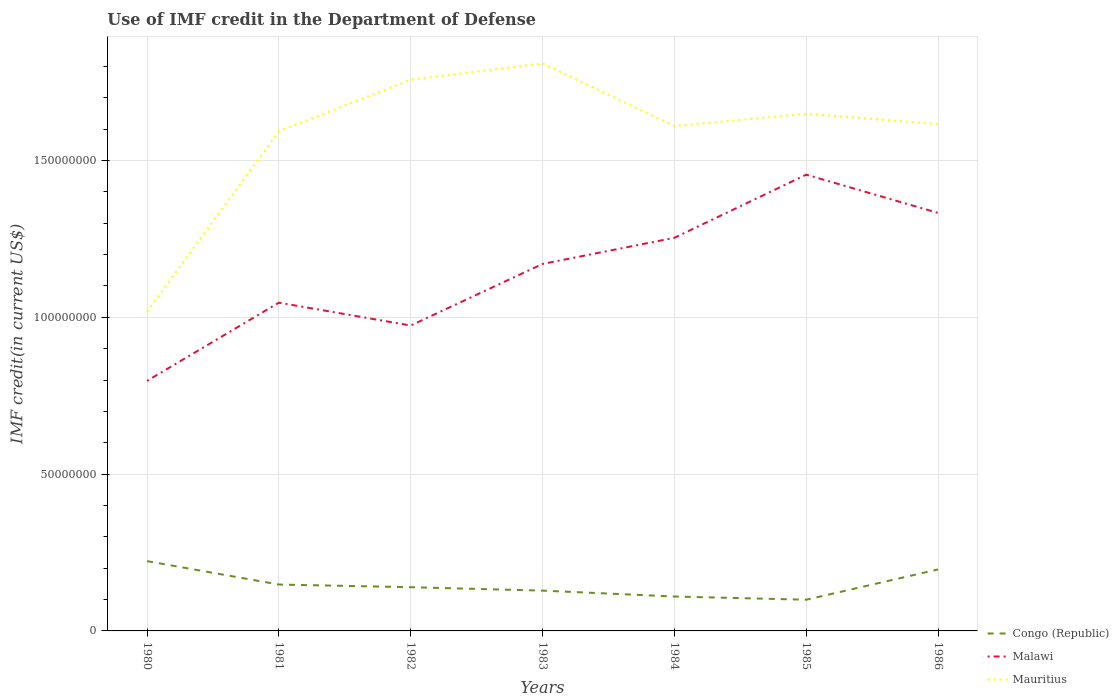Is the number of lines equal to the number of legend labels?
Give a very brief answer. Yes. Across all years, what is the maximum IMF credit in the Department of Defense in Congo (Republic)?
Provide a short and direct response. 9.95e+06. In which year was the IMF credit in the Department of Defense in Congo (Republic) maximum?
Offer a terse response. 1985. What is the total IMF credit in the Department of Defense in Mauritius in the graph?
Your response must be concise. -3.91e+06. What is the difference between the highest and the second highest IMF credit in the Department of Defense in Mauritius?
Your answer should be compact. 7.91e+07. What is the difference between the highest and the lowest IMF credit in the Department of Defense in Congo (Republic)?
Offer a terse response. 2. How many lines are there?
Your answer should be compact. 3. How many years are there in the graph?
Your answer should be very brief. 7. Are the values on the major ticks of Y-axis written in scientific E-notation?
Make the answer very short. No. Does the graph contain any zero values?
Provide a short and direct response. No. Where does the legend appear in the graph?
Keep it short and to the point. Bottom right. How many legend labels are there?
Provide a short and direct response. 3. How are the legend labels stacked?
Make the answer very short. Vertical. What is the title of the graph?
Your answer should be compact. Use of IMF credit in the Department of Defense. Does "Myanmar" appear as one of the legend labels in the graph?
Offer a terse response. No. What is the label or title of the Y-axis?
Your answer should be compact. IMF credit(in current US$). What is the IMF credit(in current US$) of Congo (Republic) in 1980?
Give a very brief answer. 2.23e+07. What is the IMF credit(in current US$) of Malawi in 1980?
Ensure brevity in your answer.  7.97e+07. What is the IMF credit(in current US$) of Mauritius in 1980?
Your answer should be compact. 1.02e+08. What is the IMF credit(in current US$) of Congo (Republic) in 1981?
Provide a succinct answer. 1.48e+07. What is the IMF credit(in current US$) in Malawi in 1981?
Provide a short and direct response. 1.05e+08. What is the IMF credit(in current US$) of Mauritius in 1981?
Ensure brevity in your answer.  1.59e+08. What is the IMF credit(in current US$) of Congo (Republic) in 1982?
Keep it short and to the point. 1.39e+07. What is the IMF credit(in current US$) of Malawi in 1982?
Your response must be concise. 9.74e+07. What is the IMF credit(in current US$) of Mauritius in 1982?
Your answer should be very brief. 1.76e+08. What is the IMF credit(in current US$) of Congo (Republic) in 1983?
Your response must be concise. 1.28e+07. What is the IMF credit(in current US$) of Malawi in 1983?
Keep it short and to the point. 1.17e+08. What is the IMF credit(in current US$) of Mauritius in 1983?
Offer a very short reply. 1.81e+08. What is the IMF credit(in current US$) in Congo (Republic) in 1984?
Your response must be concise. 1.10e+07. What is the IMF credit(in current US$) of Malawi in 1984?
Give a very brief answer. 1.25e+08. What is the IMF credit(in current US$) of Mauritius in 1984?
Your answer should be compact. 1.61e+08. What is the IMF credit(in current US$) of Congo (Republic) in 1985?
Your response must be concise. 9.95e+06. What is the IMF credit(in current US$) of Malawi in 1985?
Provide a succinct answer. 1.45e+08. What is the IMF credit(in current US$) in Mauritius in 1985?
Ensure brevity in your answer.  1.65e+08. What is the IMF credit(in current US$) of Congo (Republic) in 1986?
Ensure brevity in your answer.  1.96e+07. What is the IMF credit(in current US$) of Malawi in 1986?
Offer a very short reply. 1.33e+08. What is the IMF credit(in current US$) of Mauritius in 1986?
Keep it short and to the point. 1.62e+08. Across all years, what is the maximum IMF credit(in current US$) of Congo (Republic)?
Offer a very short reply. 2.23e+07. Across all years, what is the maximum IMF credit(in current US$) of Malawi?
Your answer should be compact. 1.45e+08. Across all years, what is the maximum IMF credit(in current US$) of Mauritius?
Provide a short and direct response. 1.81e+08. Across all years, what is the minimum IMF credit(in current US$) in Congo (Republic)?
Provide a succinct answer. 9.95e+06. Across all years, what is the minimum IMF credit(in current US$) of Malawi?
Offer a terse response. 7.97e+07. Across all years, what is the minimum IMF credit(in current US$) of Mauritius?
Offer a terse response. 1.02e+08. What is the total IMF credit(in current US$) in Congo (Republic) in the graph?
Offer a terse response. 1.04e+08. What is the total IMF credit(in current US$) in Malawi in the graph?
Provide a succinct answer. 8.03e+08. What is the total IMF credit(in current US$) of Mauritius in the graph?
Your response must be concise. 1.11e+09. What is the difference between the IMF credit(in current US$) in Congo (Republic) in 1980 and that in 1981?
Provide a succinct answer. 7.47e+06. What is the difference between the IMF credit(in current US$) of Malawi in 1980 and that in 1981?
Your answer should be compact. -2.49e+07. What is the difference between the IMF credit(in current US$) in Mauritius in 1980 and that in 1981?
Your response must be concise. -5.75e+07. What is the difference between the IMF credit(in current US$) in Congo (Republic) in 1980 and that in 1982?
Provide a short and direct response. 8.32e+06. What is the difference between the IMF credit(in current US$) in Malawi in 1980 and that in 1982?
Your answer should be very brief. -1.76e+07. What is the difference between the IMF credit(in current US$) in Mauritius in 1980 and that in 1982?
Offer a very short reply. -7.39e+07. What is the difference between the IMF credit(in current US$) of Congo (Republic) in 1980 and that in 1983?
Provide a succinct answer. 9.41e+06. What is the difference between the IMF credit(in current US$) of Malawi in 1980 and that in 1983?
Make the answer very short. -3.73e+07. What is the difference between the IMF credit(in current US$) of Mauritius in 1980 and that in 1983?
Your answer should be very brief. -7.91e+07. What is the difference between the IMF credit(in current US$) of Congo (Republic) in 1980 and that in 1984?
Provide a short and direct response. 1.13e+07. What is the difference between the IMF credit(in current US$) in Malawi in 1980 and that in 1984?
Make the answer very short. -4.56e+07. What is the difference between the IMF credit(in current US$) of Mauritius in 1980 and that in 1984?
Give a very brief answer. -5.91e+07. What is the difference between the IMF credit(in current US$) of Congo (Republic) in 1980 and that in 1985?
Your answer should be very brief. 1.23e+07. What is the difference between the IMF credit(in current US$) in Malawi in 1980 and that in 1985?
Your answer should be compact. -6.57e+07. What is the difference between the IMF credit(in current US$) of Mauritius in 1980 and that in 1985?
Offer a very short reply. -6.31e+07. What is the difference between the IMF credit(in current US$) in Congo (Republic) in 1980 and that in 1986?
Provide a succinct answer. 2.65e+06. What is the difference between the IMF credit(in current US$) of Malawi in 1980 and that in 1986?
Make the answer very short. -5.35e+07. What is the difference between the IMF credit(in current US$) in Mauritius in 1980 and that in 1986?
Offer a terse response. -5.98e+07. What is the difference between the IMF credit(in current US$) of Congo (Republic) in 1981 and that in 1982?
Offer a terse response. 8.49e+05. What is the difference between the IMF credit(in current US$) in Malawi in 1981 and that in 1982?
Offer a terse response. 7.29e+06. What is the difference between the IMF credit(in current US$) of Mauritius in 1981 and that in 1982?
Offer a very short reply. -1.64e+07. What is the difference between the IMF credit(in current US$) in Congo (Republic) in 1981 and that in 1983?
Provide a succinct answer. 1.94e+06. What is the difference between the IMF credit(in current US$) of Malawi in 1981 and that in 1983?
Give a very brief answer. -1.23e+07. What is the difference between the IMF credit(in current US$) of Mauritius in 1981 and that in 1983?
Make the answer very short. -2.16e+07. What is the difference between the IMF credit(in current US$) in Congo (Republic) in 1981 and that in 1984?
Offer a very short reply. 3.82e+06. What is the difference between the IMF credit(in current US$) in Malawi in 1981 and that in 1984?
Keep it short and to the point. -2.07e+07. What is the difference between the IMF credit(in current US$) of Mauritius in 1981 and that in 1984?
Offer a very short reply. -1.66e+06. What is the difference between the IMF credit(in current US$) in Congo (Republic) in 1981 and that in 1985?
Offer a terse response. 4.84e+06. What is the difference between the IMF credit(in current US$) of Malawi in 1981 and that in 1985?
Offer a terse response. -4.08e+07. What is the difference between the IMF credit(in current US$) in Mauritius in 1981 and that in 1985?
Give a very brief answer. -5.58e+06. What is the difference between the IMF credit(in current US$) of Congo (Republic) in 1981 and that in 1986?
Your answer should be compact. -4.81e+06. What is the difference between the IMF credit(in current US$) in Malawi in 1981 and that in 1986?
Give a very brief answer. -2.86e+07. What is the difference between the IMF credit(in current US$) in Mauritius in 1981 and that in 1986?
Ensure brevity in your answer.  -2.31e+06. What is the difference between the IMF credit(in current US$) of Congo (Republic) in 1982 and that in 1983?
Ensure brevity in your answer.  1.09e+06. What is the difference between the IMF credit(in current US$) in Malawi in 1982 and that in 1983?
Provide a short and direct response. -1.96e+07. What is the difference between the IMF credit(in current US$) in Mauritius in 1982 and that in 1983?
Your answer should be compact. -5.19e+06. What is the difference between the IMF credit(in current US$) in Congo (Republic) in 1982 and that in 1984?
Keep it short and to the point. 2.97e+06. What is the difference between the IMF credit(in current US$) in Malawi in 1982 and that in 1984?
Ensure brevity in your answer.  -2.80e+07. What is the difference between the IMF credit(in current US$) in Mauritius in 1982 and that in 1984?
Provide a succinct answer. 1.48e+07. What is the difference between the IMF credit(in current US$) in Congo (Republic) in 1982 and that in 1985?
Provide a short and direct response. 3.99e+06. What is the difference between the IMF credit(in current US$) of Malawi in 1982 and that in 1985?
Provide a short and direct response. -4.81e+07. What is the difference between the IMF credit(in current US$) of Mauritius in 1982 and that in 1985?
Your response must be concise. 1.09e+07. What is the difference between the IMF credit(in current US$) of Congo (Republic) in 1982 and that in 1986?
Make the answer very short. -5.66e+06. What is the difference between the IMF credit(in current US$) in Malawi in 1982 and that in 1986?
Provide a succinct answer. -3.59e+07. What is the difference between the IMF credit(in current US$) of Mauritius in 1982 and that in 1986?
Make the answer very short. 1.41e+07. What is the difference between the IMF credit(in current US$) in Congo (Republic) in 1983 and that in 1984?
Provide a succinct answer. 1.88e+06. What is the difference between the IMF credit(in current US$) in Malawi in 1983 and that in 1984?
Keep it short and to the point. -8.33e+06. What is the difference between the IMF credit(in current US$) in Mauritius in 1983 and that in 1984?
Offer a terse response. 2.00e+07. What is the difference between the IMF credit(in current US$) in Congo (Republic) in 1983 and that in 1985?
Your answer should be very brief. 2.90e+06. What is the difference between the IMF credit(in current US$) in Malawi in 1983 and that in 1985?
Your answer should be compact. -2.85e+07. What is the difference between the IMF credit(in current US$) of Mauritius in 1983 and that in 1985?
Give a very brief answer. 1.61e+07. What is the difference between the IMF credit(in current US$) of Congo (Republic) in 1983 and that in 1986?
Keep it short and to the point. -6.75e+06. What is the difference between the IMF credit(in current US$) in Malawi in 1983 and that in 1986?
Make the answer very short. -1.63e+07. What is the difference between the IMF credit(in current US$) in Mauritius in 1983 and that in 1986?
Offer a terse response. 1.93e+07. What is the difference between the IMF credit(in current US$) in Congo (Republic) in 1984 and that in 1985?
Offer a very short reply. 1.02e+06. What is the difference between the IMF credit(in current US$) of Malawi in 1984 and that in 1985?
Make the answer very short. -2.01e+07. What is the difference between the IMF credit(in current US$) in Mauritius in 1984 and that in 1985?
Keep it short and to the point. -3.91e+06. What is the difference between the IMF credit(in current US$) of Congo (Republic) in 1984 and that in 1986?
Offer a very short reply. -8.63e+06. What is the difference between the IMF credit(in current US$) in Malawi in 1984 and that in 1986?
Provide a short and direct response. -7.93e+06. What is the difference between the IMF credit(in current US$) in Mauritius in 1984 and that in 1986?
Ensure brevity in your answer.  -6.48e+05. What is the difference between the IMF credit(in current US$) in Congo (Republic) in 1985 and that in 1986?
Your response must be concise. -9.65e+06. What is the difference between the IMF credit(in current US$) of Malawi in 1985 and that in 1986?
Ensure brevity in your answer.  1.22e+07. What is the difference between the IMF credit(in current US$) of Mauritius in 1985 and that in 1986?
Your answer should be very brief. 3.27e+06. What is the difference between the IMF credit(in current US$) in Congo (Republic) in 1980 and the IMF credit(in current US$) in Malawi in 1981?
Your answer should be very brief. -8.24e+07. What is the difference between the IMF credit(in current US$) in Congo (Republic) in 1980 and the IMF credit(in current US$) in Mauritius in 1981?
Provide a short and direct response. -1.37e+08. What is the difference between the IMF credit(in current US$) of Malawi in 1980 and the IMF credit(in current US$) of Mauritius in 1981?
Make the answer very short. -7.96e+07. What is the difference between the IMF credit(in current US$) of Congo (Republic) in 1980 and the IMF credit(in current US$) of Malawi in 1982?
Your answer should be very brief. -7.51e+07. What is the difference between the IMF credit(in current US$) in Congo (Republic) in 1980 and the IMF credit(in current US$) in Mauritius in 1982?
Your response must be concise. -1.54e+08. What is the difference between the IMF credit(in current US$) in Malawi in 1980 and the IMF credit(in current US$) in Mauritius in 1982?
Your answer should be very brief. -9.60e+07. What is the difference between the IMF credit(in current US$) of Congo (Republic) in 1980 and the IMF credit(in current US$) of Malawi in 1983?
Your answer should be very brief. -9.48e+07. What is the difference between the IMF credit(in current US$) of Congo (Republic) in 1980 and the IMF credit(in current US$) of Mauritius in 1983?
Provide a short and direct response. -1.59e+08. What is the difference between the IMF credit(in current US$) in Malawi in 1980 and the IMF credit(in current US$) in Mauritius in 1983?
Provide a short and direct response. -1.01e+08. What is the difference between the IMF credit(in current US$) in Congo (Republic) in 1980 and the IMF credit(in current US$) in Malawi in 1984?
Ensure brevity in your answer.  -1.03e+08. What is the difference between the IMF credit(in current US$) in Congo (Republic) in 1980 and the IMF credit(in current US$) in Mauritius in 1984?
Offer a very short reply. -1.39e+08. What is the difference between the IMF credit(in current US$) of Malawi in 1980 and the IMF credit(in current US$) of Mauritius in 1984?
Provide a succinct answer. -8.13e+07. What is the difference between the IMF credit(in current US$) in Congo (Republic) in 1980 and the IMF credit(in current US$) in Malawi in 1985?
Provide a short and direct response. -1.23e+08. What is the difference between the IMF credit(in current US$) of Congo (Republic) in 1980 and the IMF credit(in current US$) of Mauritius in 1985?
Ensure brevity in your answer.  -1.43e+08. What is the difference between the IMF credit(in current US$) in Malawi in 1980 and the IMF credit(in current US$) in Mauritius in 1985?
Ensure brevity in your answer.  -8.52e+07. What is the difference between the IMF credit(in current US$) of Congo (Republic) in 1980 and the IMF credit(in current US$) of Malawi in 1986?
Make the answer very short. -1.11e+08. What is the difference between the IMF credit(in current US$) in Congo (Republic) in 1980 and the IMF credit(in current US$) in Mauritius in 1986?
Your response must be concise. -1.39e+08. What is the difference between the IMF credit(in current US$) in Malawi in 1980 and the IMF credit(in current US$) in Mauritius in 1986?
Keep it short and to the point. -8.19e+07. What is the difference between the IMF credit(in current US$) of Congo (Republic) in 1981 and the IMF credit(in current US$) of Malawi in 1982?
Offer a very short reply. -8.26e+07. What is the difference between the IMF credit(in current US$) of Congo (Republic) in 1981 and the IMF credit(in current US$) of Mauritius in 1982?
Your answer should be very brief. -1.61e+08. What is the difference between the IMF credit(in current US$) of Malawi in 1981 and the IMF credit(in current US$) of Mauritius in 1982?
Make the answer very short. -7.11e+07. What is the difference between the IMF credit(in current US$) of Congo (Republic) in 1981 and the IMF credit(in current US$) of Malawi in 1983?
Give a very brief answer. -1.02e+08. What is the difference between the IMF credit(in current US$) in Congo (Republic) in 1981 and the IMF credit(in current US$) in Mauritius in 1983?
Make the answer very short. -1.66e+08. What is the difference between the IMF credit(in current US$) of Malawi in 1981 and the IMF credit(in current US$) of Mauritius in 1983?
Give a very brief answer. -7.63e+07. What is the difference between the IMF credit(in current US$) in Congo (Republic) in 1981 and the IMF credit(in current US$) in Malawi in 1984?
Provide a short and direct response. -1.11e+08. What is the difference between the IMF credit(in current US$) of Congo (Republic) in 1981 and the IMF credit(in current US$) of Mauritius in 1984?
Provide a short and direct response. -1.46e+08. What is the difference between the IMF credit(in current US$) of Malawi in 1981 and the IMF credit(in current US$) of Mauritius in 1984?
Ensure brevity in your answer.  -5.63e+07. What is the difference between the IMF credit(in current US$) of Congo (Republic) in 1981 and the IMF credit(in current US$) of Malawi in 1985?
Provide a succinct answer. -1.31e+08. What is the difference between the IMF credit(in current US$) of Congo (Republic) in 1981 and the IMF credit(in current US$) of Mauritius in 1985?
Provide a succinct answer. -1.50e+08. What is the difference between the IMF credit(in current US$) of Malawi in 1981 and the IMF credit(in current US$) of Mauritius in 1985?
Provide a short and direct response. -6.02e+07. What is the difference between the IMF credit(in current US$) in Congo (Republic) in 1981 and the IMF credit(in current US$) in Malawi in 1986?
Keep it short and to the point. -1.18e+08. What is the difference between the IMF credit(in current US$) of Congo (Republic) in 1981 and the IMF credit(in current US$) of Mauritius in 1986?
Offer a terse response. -1.47e+08. What is the difference between the IMF credit(in current US$) in Malawi in 1981 and the IMF credit(in current US$) in Mauritius in 1986?
Give a very brief answer. -5.70e+07. What is the difference between the IMF credit(in current US$) of Congo (Republic) in 1982 and the IMF credit(in current US$) of Malawi in 1983?
Keep it short and to the point. -1.03e+08. What is the difference between the IMF credit(in current US$) of Congo (Republic) in 1982 and the IMF credit(in current US$) of Mauritius in 1983?
Provide a short and direct response. -1.67e+08. What is the difference between the IMF credit(in current US$) of Malawi in 1982 and the IMF credit(in current US$) of Mauritius in 1983?
Ensure brevity in your answer.  -8.36e+07. What is the difference between the IMF credit(in current US$) in Congo (Republic) in 1982 and the IMF credit(in current US$) in Malawi in 1984?
Ensure brevity in your answer.  -1.11e+08. What is the difference between the IMF credit(in current US$) in Congo (Republic) in 1982 and the IMF credit(in current US$) in Mauritius in 1984?
Your answer should be compact. -1.47e+08. What is the difference between the IMF credit(in current US$) of Malawi in 1982 and the IMF credit(in current US$) of Mauritius in 1984?
Ensure brevity in your answer.  -6.36e+07. What is the difference between the IMF credit(in current US$) in Congo (Republic) in 1982 and the IMF credit(in current US$) in Malawi in 1985?
Your response must be concise. -1.32e+08. What is the difference between the IMF credit(in current US$) in Congo (Republic) in 1982 and the IMF credit(in current US$) in Mauritius in 1985?
Keep it short and to the point. -1.51e+08. What is the difference between the IMF credit(in current US$) in Malawi in 1982 and the IMF credit(in current US$) in Mauritius in 1985?
Provide a short and direct response. -6.75e+07. What is the difference between the IMF credit(in current US$) of Congo (Republic) in 1982 and the IMF credit(in current US$) of Malawi in 1986?
Offer a terse response. -1.19e+08. What is the difference between the IMF credit(in current US$) of Congo (Republic) in 1982 and the IMF credit(in current US$) of Mauritius in 1986?
Offer a very short reply. -1.48e+08. What is the difference between the IMF credit(in current US$) in Malawi in 1982 and the IMF credit(in current US$) in Mauritius in 1986?
Make the answer very short. -6.43e+07. What is the difference between the IMF credit(in current US$) of Congo (Republic) in 1983 and the IMF credit(in current US$) of Malawi in 1984?
Give a very brief answer. -1.12e+08. What is the difference between the IMF credit(in current US$) in Congo (Republic) in 1983 and the IMF credit(in current US$) in Mauritius in 1984?
Your response must be concise. -1.48e+08. What is the difference between the IMF credit(in current US$) of Malawi in 1983 and the IMF credit(in current US$) of Mauritius in 1984?
Ensure brevity in your answer.  -4.40e+07. What is the difference between the IMF credit(in current US$) in Congo (Republic) in 1983 and the IMF credit(in current US$) in Malawi in 1985?
Keep it short and to the point. -1.33e+08. What is the difference between the IMF credit(in current US$) of Congo (Republic) in 1983 and the IMF credit(in current US$) of Mauritius in 1985?
Your response must be concise. -1.52e+08. What is the difference between the IMF credit(in current US$) of Malawi in 1983 and the IMF credit(in current US$) of Mauritius in 1985?
Provide a succinct answer. -4.79e+07. What is the difference between the IMF credit(in current US$) of Congo (Republic) in 1983 and the IMF credit(in current US$) of Malawi in 1986?
Your answer should be compact. -1.20e+08. What is the difference between the IMF credit(in current US$) of Congo (Republic) in 1983 and the IMF credit(in current US$) of Mauritius in 1986?
Make the answer very short. -1.49e+08. What is the difference between the IMF credit(in current US$) in Malawi in 1983 and the IMF credit(in current US$) in Mauritius in 1986?
Make the answer very short. -4.46e+07. What is the difference between the IMF credit(in current US$) in Congo (Republic) in 1984 and the IMF credit(in current US$) in Malawi in 1985?
Provide a short and direct response. -1.34e+08. What is the difference between the IMF credit(in current US$) in Congo (Republic) in 1984 and the IMF credit(in current US$) in Mauritius in 1985?
Offer a terse response. -1.54e+08. What is the difference between the IMF credit(in current US$) in Malawi in 1984 and the IMF credit(in current US$) in Mauritius in 1985?
Provide a succinct answer. -3.96e+07. What is the difference between the IMF credit(in current US$) of Congo (Republic) in 1984 and the IMF credit(in current US$) of Malawi in 1986?
Keep it short and to the point. -1.22e+08. What is the difference between the IMF credit(in current US$) in Congo (Republic) in 1984 and the IMF credit(in current US$) in Mauritius in 1986?
Offer a very short reply. -1.51e+08. What is the difference between the IMF credit(in current US$) in Malawi in 1984 and the IMF credit(in current US$) in Mauritius in 1986?
Provide a short and direct response. -3.63e+07. What is the difference between the IMF credit(in current US$) in Congo (Republic) in 1985 and the IMF credit(in current US$) in Malawi in 1986?
Your response must be concise. -1.23e+08. What is the difference between the IMF credit(in current US$) of Congo (Republic) in 1985 and the IMF credit(in current US$) of Mauritius in 1986?
Provide a succinct answer. -1.52e+08. What is the difference between the IMF credit(in current US$) in Malawi in 1985 and the IMF credit(in current US$) in Mauritius in 1986?
Provide a short and direct response. -1.62e+07. What is the average IMF credit(in current US$) of Congo (Republic) per year?
Your answer should be very brief. 1.49e+07. What is the average IMF credit(in current US$) of Malawi per year?
Offer a very short reply. 1.15e+08. What is the average IMF credit(in current US$) of Mauritius per year?
Your response must be concise. 1.58e+08. In the year 1980, what is the difference between the IMF credit(in current US$) of Congo (Republic) and IMF credit(in current US$) of Malawi?
Ensure brevity in your answer.  -5.75e+07. In the year 1980, what is the difference between the IMF credit(in current US$) of Congo (Republic) and IMF credit(in current US$) of Mauritius?
Ensure brevity in your answer.  -7.96e+07. In the year 1980, what is the difference between the IMF credit(in current US$) in Malawi and IMF credit(in current US$) in Mauritius?
Give a very brief answer. -2.21e+07. In the year 1981, what is the difference between the IMF credit(in current US$) in Congo (Republic) and IMF credit(in current US$) in Malawi?
Make the answer very short. -8.99e+07. In the year 1981, what is the difference between the IMF credit(in current US$) of Congo (Republic) and IMF credit(in current US$) of Mauritius?
Provide a succinct answer. -1.45e+08. In the year 1981, what is the difference between the IMF credit(in current US$) in Malawi and IMF credit(in current US$) in Mauritius?
Provide a short and direct response. -5.47e+07. In the year 1982, what is the difference between the IMF credit(in current US$) of Congo (Republic) and IMF credit(in current US$) of Malawi?
Give a very brief answer. -8.34e+07. In the year 1982, what is the difference between the IMF credit(in current US$) in Congo (Republic) and IMF credit(in current US$) in Mauritius?
Offer a terse response. -1.62e+08. In the year 1982, what is the difference between the IMF credit(in current US$) of Malawi and IMF credit(in current US$) of Mauritius?
Keep it short and to the point. -7.84e+07. In the year 1983, what is the difference between the IMF credit(in current US$) in Congo (Republic) and IMF credit(in current US$) in Malawi?
Offer a very short reply. -1.04e+08. In the year 1983, what is the difference between the IMF credit(in current US$) in Congo (Republic) and IMF credit(in current US$) in Mauritius?
Your response must be concise. -1.68e+08. In the year 1983, what is the difference between the IMF credit(in current US$) of Malawi and IMF credit(in current US$) of Mauritius?
Make the answer very short. -6.39e+07. In the year 1984, what is the difference between the IMF credit(in current US$) of Congo (Republic) and IMF credit(in current US$) of Malawi?
Keep it short and to the point. -1.14e+08. In the year 1984, what is the difference between the IMF credit(in current US$) of Congo (Republic) and IMF credit(in current US$) of Mauritius?
Keep it short and to the point. -1.50e+08. In the year 1984, what is the difference between the IMF credit(in current US$) of Malawi and IMF credit(in current US$) of Mauritius?
Ensure brevity in your answer.  -3.56e+07. In the year 1985, what is the difference between the IMF credit(in current US$) of Congo (Republic) and IMF credit(in current US$) of Malawi?
Ensure brevity in your answer.  -1.36e+08. In the year 1985, what is the difference between the IMF credit(in current US$) of Congo (Republic) and IMF credit(in current US$) of Mauritius?
Provide a short and direct response. -1.55e+08. In the year 1985, what is the difference between the IMF credit(in current US$) of Malawi and IMF credit(in current US$) of Mauritius?
Provide a succinct answer. -1.94e+07. In the year 1986, what is the difference between the IMF credit(in current US$) in Congo (Republic) and IMF credit(in current US$) in Malawi?
Your answer should be compact. -1.14e+08. In the year 1986, what is the difference between the IMF credit(in current US$) in Congo (Republic) and IMF credit(in current US$) in Mauritius?
Provide a short and direct response. -1.42e+08. In the year 1986, what is the difference between the IMF credit(in current US$) of Malawi and IMF credit(in current US$) of Mauritius?
Make the answer very short. -2.84e+07. What is the ratio of the IMF credit(in current US$) of Congo (Republic) in 1980 to that in 1981?
Your response must be concise. 1.5. What is the ratio of the IMF credit(in current US$) in Malawi in 1980 to that in 1981?
Offer a very short reply. 0.76. What is the ratio of the IMF credit(in current US$) in Mauritius in 1980 to that in 1981?
Keep it short and to the point. 0.64. What is the ratio of the IMF credit(in current US$) in Congo (Republic) in 1980 to that in 1982?
Offer a very short reply. 1.6. What is the ratio of the IMF credit(in current US$) in Malawi in 1980 to that in 1982?
Your answer should be compact. 0.82. What is the ratio of the IMF credit(in current US$) in Mauritius in 1980 to that in 1982?
Provide a succinct answer. 0.58. What is the ratio of the IMF credit(in current US$) of Congo (Republic) in 1980 to that in 1983?
Provide a succinct answer. 1.73. What is the ratio of the IMF credit(in current US$) in Malawi in 1980 to that in 1983?
Offer a terse response. 0.68. What is the ratio of the IMF credit(in current US$) in Mauritius in 1980 to that in 1983?
Your response must be concise. 0.56. What is the ratio of the IMF credit(in current US$) of Congo (Republic) in 1980 to that in 1984?
Offer a terse response. 2.03. What is the ratio of the IMF credit(in current US$) in Malawi in 1980 to that in 1984?
Keep it short and to the point. 0.64. What is the ratio of the IMF credit(in current US$) of Mauritius in 1980 to that in 1984?
Ensure brevity in your answer.  0.63. What is the ratio of the IMF credit(in current US$) in Congo (Republic) in 1980 to that in 1985?
Your answer should be compact. 2.24. What is the ratio of the IMF credit(in current US$) of Malawi in 1980 to that in 1985?
Your response must be concise. 0.55. What is the ratio of the IMF credit(in current US$) in Mauritius in 1980 to that in 1985?
Your response must be concise. 0.62. What is the ratio of the IMF credit(in current US$) of Congo (Republic) in 1980 to that in 1986?
Your answer should be compact. 1.14. What is the ratio of the IMF credit(in current US$) of Malawi in 1980 to that in 1986?
Your answer should be very brief. 0.6. What is the ratio of the IMF credit(in current US$) in Mauritius in 1980 to that in 1986?
Provide a succinct answer. 0.63. What is the ratio of the IMF credit(in current US$) in Congo (Republic) in 1981 to that in 1982?
Provide a succinct answer. 1.06. What is the ratio of the IMF credit(in current US$) of Malawi in 1981 to that in 1982?
Make the answer very short. 1.07. What is the ratio of the IMF credit(in current US$) in Mauritius in 1981 to that in 1982?
Keep it short and to the point. 0.91. What is the ratio of the IMF credit(in current US$) in Congo (Republic) in 1981 to that in 1983?
Your response must be concise. 1.15. What is the ratio of the IMF credit(in current US$) in Malawi in 1981 to that in 1983?
Give a very brief answer. 0.89. What is the ratio of the IMF credit(in current US$) of Mauritius in 1981 to that in 1983?
Give a very brief answer. 0.88. What is the ratio of the IMF credit(in current US$) of Congo (Republic) in 1981 to that in 1984?
Give a very brief answer. 1.35. What is the ratio of the IMF credit(in current US$) in Malawi in 1981 to that in 1984?
Your answer should be compact. 0.83. What is the ratio of the IMF credit(in current US$) of Mauritius in 1981 to that in 1984?
Provide a succinct answer. 0.99. What is the ratio of the IMF credit(in current US$) of Congo (Republic) in 1981 to that in 1985?
Your answer should be very brief. 1.49. What is the ratio of the IMF credit(in current US$) of Malawi in 1981 to that in 1985?
Offer a very short reply. 0.72. What is the ratio of the IMF credit(in current US$) in Mauritius in 1981 to that in 1985?
Your response must be concise. 0.97. What is the ratio of the IMF credit(in current US$) of Congo (Republic) in 1981 to that in 1986?
Ensure brevity in your answer.  0.75. What is the ratio of the IMF credit(in current US$) of Malawi in 1981 to that in 1986?
Offer a terse response. 0.79. What is the ratio of the IMF credit(in current US$) of Mauritius in 1981 to that in 1986?
Keep it short and to the point. 0.99. What is the ratio of the IMF credit(in current US$) of Congo (Republic) in 1982 to that in 1983?
Ensure brevity in your answer.  1.08. What is the ratio of the IMF credit(in current US$) in Malawi in 1982 to that in 1983?
Provide a short and direct response. 0.83. What is the ratio of the IMF credit(in current US$) of Mauritius in 1982 to that in 1983?
Offer a terse response. 0.97. What is the ratio of the IMF credit(in current US$) of Congo (Republic) in 1982 to that in 1984?
Offer a very short reply. 1.27. What is the ratio of the IMF credit(in current US$) in Malawi in 1982 to that in 1984?
Your answer should be compact. 0.78. What is the ratio of the IMF credit(in current US$) in Mauritius in 1982 to that in 1984?
Your answer should be very brief. 1.09. What is the ratio of the IMF credit(in current US$) of Congo (Republic) in 1982 to that in 1985?
Give a very brief answer. 1.4. What is the ratio of the IMF credit(in current US$) in Malawi in 1982 to that in 1985?
Your answer should be very brief. 0.67. What is the ratio of the IMF credit(in current US$) of Mauritius in 1982 to that in 1985?
Offer a very short reply. 1.07. What is the ratio of the IMF credit(in current US$) in Congo (Republic) in 1982 to that in 1986?
Your response must be concise. 0.71. What is the ratio of the IMF credit(in current US$) in Malawi in 1982 to that in 1986?
Provide a short and direct response. 0.73. What is the ratio of the IMF credit(in current US$) of Mauritius in 1982 to that in 1986?
Keep it short and to the point. 1.09. What is the ratio of the IMF credit(in current US$) in Congo (Republic) in 1983 to that in 1984?
Offer a very short reply. 1.17. What is the ratio of the IMF credit(in current US$) in Malawi in 1983 to that in 1984?
Your answer should be very brief. 0.93. What is the ratio of the IMF credit(in current US$) of Mauritius in 1983 to that in 1984?
Ensure brevity in your answer.  1.12. What is the ratio of the IMF credit(in current US$) in Congo (Republic) in 1983 to that in 1985?
Provide a short and direct response. 1.29. What is the ratio of the IMF credit(in current US$) in Malawi in 1983 to that in 1985?
Offer a terse response. 0.8. What is the ratio of the IMF credit(in current US$) in Mauritius in 1983 to that in 1985?
Offer a very short reply. 1.1. What is the ratio of the IMF credit(in current US$) of Congo (Republic) in 1983 to that in 1986?
Give a very brief answer. 0.66. What is the ratio of the IMF credit(in current US$) in Malawi in 1983 to that in 1986?
Provide a succinct answer. 0.88. What is the ratio of the IMF credit(in current US$) of Mauritius in 1983 to that in 1986?
Provide a succinct answer. 1.12. What is the ratio of the IMF credit(in current US$) in Congo (Republic) in 1984 to that in 1985?
Give a very brief answer. 1.1. What is the ratio of the IMF credit(in current US$) in Malawi in 1984 to that in 1985?
Keep it short and to the point. 0.86. What is the ratio of the IMF credit(in current US$) in Mauritius in 1984 to that in 1985?
Your answer should be very brief. 0.98. What is the ratio of the IMF credit(in current US$) in Congo (Republic) in 1984 to that in 1986?
Keep it short and to the point. 0.56. What is the ratio of the IMF credit(in current US$) of Malawi in 1984 to that in 1986?
Your response must be concise. 0.94. What is the ratio of the IMF credit(in current US$) in Congo (Republic) in 1985 to that in 1986?
Your answer should be very brief. 0.51. What is the ratio of the IMF credit(in current US$) in Malawi in 1985 to that in 1986?
Provide a short and direct response. 1.09. What is the ratio of the IMF credit(in current US$) of Mauritius in 1985 to that in 1986?
Give a very brief answer. 1.02. What is the difference between the highest and the second highest IMF credit(in current US$) of Congo (Republic)?
Make the answer very short. 2.65e+06. What is the difference between the highest and the second highest IMF credit(in current US$) of Malawi?
Your answer should be compact. 1.22e+07. What is the difference between the highest and the second highest IMF credit(in current US$) of Mauritius?
Provide a succinct answer. 5.19e+06. What is the difference between the highest and the lowest IMF credit(in current US$) in Congo (Republic)?
Offer a terse response. 1.23e+07. What is the difference between the highest and the lowest IMF credit(in current US$) of Malawi?
Offer a terse response. 6.57e+07. What is the difference between the highest and the lowest IMF credit(in current US$) in Mauritius?
Keep it short and to the point. 7.91e+07. 